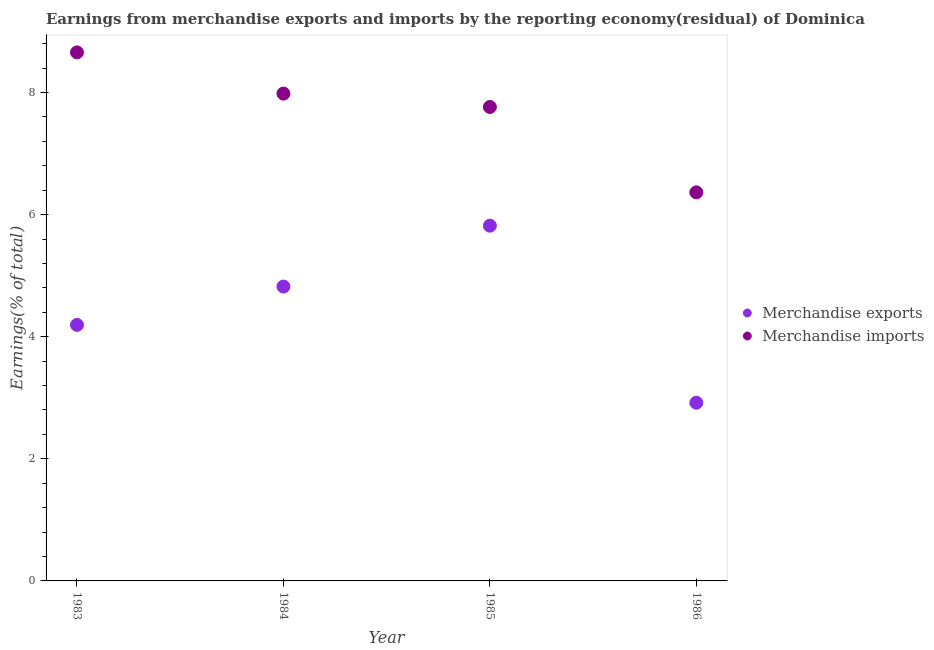Is the number of dotlines equal to the number of legend labels?
Your response must be concise. Yes. What is the earnings from merchandise exports in 1983?
Your response must be concise. 4.19. Across all years, what is the maximum earnings from merchandise imports?
Ensure brevity in your answer.  8.66. Across all years, what is the minimum earnings from merchandise exports?
Ensure brevity in your answer.  2.92. What is the total earnings from merchandise imports in the graph?
Your answer should be compact. 30.77. What is the difference between the earnings from merchandise imports in 1983 and that in 1985?
Give a very brief answer. 0.89. What is the difference between the earnings from merchandise exports in 1983 and the earnings from merchandise imports in 1984?
Provide a short and direct response. -3.79. What is the average earnings from merchandise imports per year?
Make the answer very short. 7.69. In the year 1984, what is the difference between the earnings from merchandise exports and earnings from merchandise imports?
Make the answer very short. -3.16. What is the ratio of the earnings from merchandise imports in 1984 to that in 1986?
Give a very brief answer. 1.25. Is the difference between the earnings from merchandise imports in 1984 and 1986 greater than the difference between the earnings from merchandise exports in 1984 and 1986?
Make the answer very short. No. What is the difference between the highest and the second highest earnings from merchandise exports?
Your response must be concise. 1. What is the difference between the highest and the lowest earnings from merchandise exports?
Provide a succinct answer. 2.9. In how many years, is the earnings from merchandise exports greater than the average earnings from merchandise exports taken over all years?
Provide a short and direct response. 2. Does the earnings from merchandise imports monotonically increase over the years?
Your response must be concise. No. Is the earnings from merchandise exports strictly greater than the earnings from merchandise imports over the years?
Your response must be concise. No. How many years are there in the graph?
Keep it short and to the point. 4. Does the graph contain any zero values?
Ensure brevity in your answer.  No. Does the graph contain grids?
Ensure brevity in your answer.  No. How many legend labels are there?
Make the answer very short. 2. What is the title of the graph?
Your answer should be very brief. Earnings from merchandise exports and imports by the reporting economy(residual) of Dominica. Does "Non-pregnant women" appear as one of the legend labels in the graph?
Provide a short and direct response. No. What is the label or title of the Y-axis?
Ensure brevity in your answer.  Earnings(% of total). What is the Earnings(% of total) in Merchandise exports in 1983?
Give a very brief answer. 4.19. What is the Earnings(% of total) in Merchandise imports in 1983?
Give a very brief answer. 8.66. What is the Earnings(% of total) of Merchandise exports in 1984?
Provide a succinct answer. 4.82. What is the Earnings(% of total) in Merchandise imports in 1984?
Keep it short and to the point. 7.98. What is the Earnings(% of total) in Merchandise exports in 1985?
Your answer should be compact. 5.82. What is the Earnings(% of total) in Merchandise imports in 1985?
Ensure brevity in your answer.  7.76. What is the Earnings(% of total) of Merchandise exports in 1986?
Your answer should be compact. 2.92. What is the Earnings(% of total) of Merchandise imports in 1986?
Offer a very short reply. 6.37. Across all years, what is the maximum Earnings(% of total) of Merchandise exports?
Offer a terse response. 5.82. Across all years, what is the maximum Earnings(% of total) of Merchandise imports?
Offer a terse response. 8.66. Across all years, what is the minimum Earnings(% of total) of Merchandise exports?
Ensure brevity in your answer.  2.92. Across all years, what is the minimum Earnings(% of total) of Merchandise imports?
Make the answer very short. 6.37. What is the total Earnings(% of total) of Merchandise exports in the graph?
Make the answer very short. 17.75. What is the total Earnings(% of total) of Merchandise imports in the graph?
Your answer should be very brief. 30.77. What is the difference between the Earnings(% of total) in Merchandise exports in 1983 and that in 1984?
Ensure brevity in your answer.  -0.63. What is the difference between the Earnings(% of total) in Merchandise imports in 1983 and that in 1984?
Ensure brevity in your answer.  0.68. What is the difference between the Earnings(% of total) of Merchandise exports in 1983 and that in 1985?
Your response must be concise. -1.63. What is the difference between the Earnings(% of total) in Merchandise imports in 1983 and that in 1985?
Offer a very short reply. 0.89. What is the difference between the Earnings(% of total) in Merchandise exports in 1983 and that in 1986?
Ensure brevity in your answer.  1.27. What is the difference between the Earnings(% of total) in Merchandise imports in 1983 and that in 1986?
Ensure brevity in your answer.  2.29. What is the difference between the Earnings(% of total) of Merchandise exports in 1984 and that in 1985?
Make the answer very short. -1. What is the difference between the Earnings(% of total) in Merchandise imports in 1984 and that in 1985?
Your response must be concise. 0.22. What is the difference between the Earnings(% of total) in Merchandise exports in 1984 and that in 1986?
Offer a very short reply. 1.9. What is the difference between the Earnings(% of total) of Merchandise imports in 1984 and that in 1986?
Provide a short and direct response. 1.62. What is the difference between the Earnings(% of total) in Merchandise exports in 1985 and that in 1986?
Keep it short and to the point. 2.9. What is the difference between the Earnings(% of total) in Merchandise imports in 1985 and that in 1986?
Give a very brief answer. 1.4. What is the difference between the Earnings(% of total) in Merchandise exports in 1983 and the Earnings(% of total) in Merchandise imports in 1984?
Make the answer very short. -3.79. What is the difference between the Earnings(% of total) in Merchandise exports in 1983 and the Earnings(% of total) in Merchandise imports in 1985?
Your answer should be compact. -3.57. What is the difference between the Earnings(% of total) of Merchandise exports in 1983 and the Earnings(% of total) of Merchandise imports in 1986?
Give a very brief answer. -2.17. What is the difference between the Earnings(% of total) in Merchandise exports in 1984 and the Earnings(% of total) in Merchandise imports in 1985?
Your answer should be compact. -2.94. What is the difference between the Earnings(% of total) in Merchandise exports in 1984 and the Earnings(% of total) in Merchandise imports in 1986?
Offer a terse response. -1.54. What is the difference between the Earnings(% of total) in Merchandise exports in 1985 and the Earnings(% of total) in Merchandise imports in 1986?
Your answer should be very brief. -0.55. What is the average Earnings(% of total) in Merchandise exports per year?
Give a very brief answer. 4.44. What is the average Earnings(% of total) in Merchandise imports per year?
Keep it short and to the point. 7.69. In the year 1983, what is the difference between the Earnings(% of total) of Merchandise exports and Earnings(% of total) of Merchandise imports?
Your answer should be compact. -4.46. In the year 1984, what is the difference between the Earnings(% of total) of Merchandise exports and Earnings(% of total) of Merchandise imports?
Your answer should be compact. -3.16. In the year 1985, what is the difference between the Earnings(% of total) in Merchandise exports and Earnings(% of total) in Merchandise imports?
Your response must be concise. -1.94. In the year 1986, what is the difference between the Earnings(% of total) in Merchandise exports and Earnings(% of total) in Merchandise imports?
Your response must be concise. -3.45. What is the ratio of the Earnings(% of total) of Merchandise exports in 1983 to that in 1984?
Your response must be concise. 0.87. What is the ratio of the Earnings(% of total) in Merchandise imports in 1983 to that in 1984?
Make the answer very short. 1.08. What is the ratio of the Earnings(% of total) in Merchandise exports in 1983 to that in 1985?
Give a very brief answer. 0.72. What is the ratio of the Earnings(% of total) of Merchandise imports in 1983 to that in 1985?
Your answer should be very brief. 1.12. What is the ratio of the Earnings(% of total) in Merchandise exports in 1983 to that in 1986?
Offer a terse response. 1.44. What is the ratio of the Earnings(% of total) of Merchandise imports in 1983 to that in 1986?
Your answer should be very brief. 1.36. What is the ratio of the Earnings(% of total) of Merchandise exports in 1984 to that in 1985?
Give a very brief answer. 0.83. What is the ratio of the Earnings(% of total) of Merchandise imports in 1984 to that in 1985?
Keep it short and to the point. 1.03. What is the ratio of the Earnings(% of total) of Merchandise exports in 1984 to that in 1986?
Give a very brief answer. 1.65. What is the ratio of the Earnings(% of total) in Merchandise imports in 1984 to that in 1986?
Your answer should be very brief. 1.25. What is the ratio of the Earnings(% of total) in Merchandise exports in 1985 to that in 1986?
Your answer should be compact. 1.99. What is the ratio of the Earnings(% of total) of Merchandise imports in 1985 to that in 1986?
Your answer should be very brief. 1.22. What is the difference between the highest and the second highest Earnings(% of total) in Merchandise imports?
Your response must be concise. 0.68. What is the difference between the highest and the lowest Earnings(% of total) of Merchandise exports?
Offer a terse response. 2.9. What is the difference between the highest and the lowest Earnings(% of total) in Merchandise imports?
Provide a short and direct response. 2.29. 